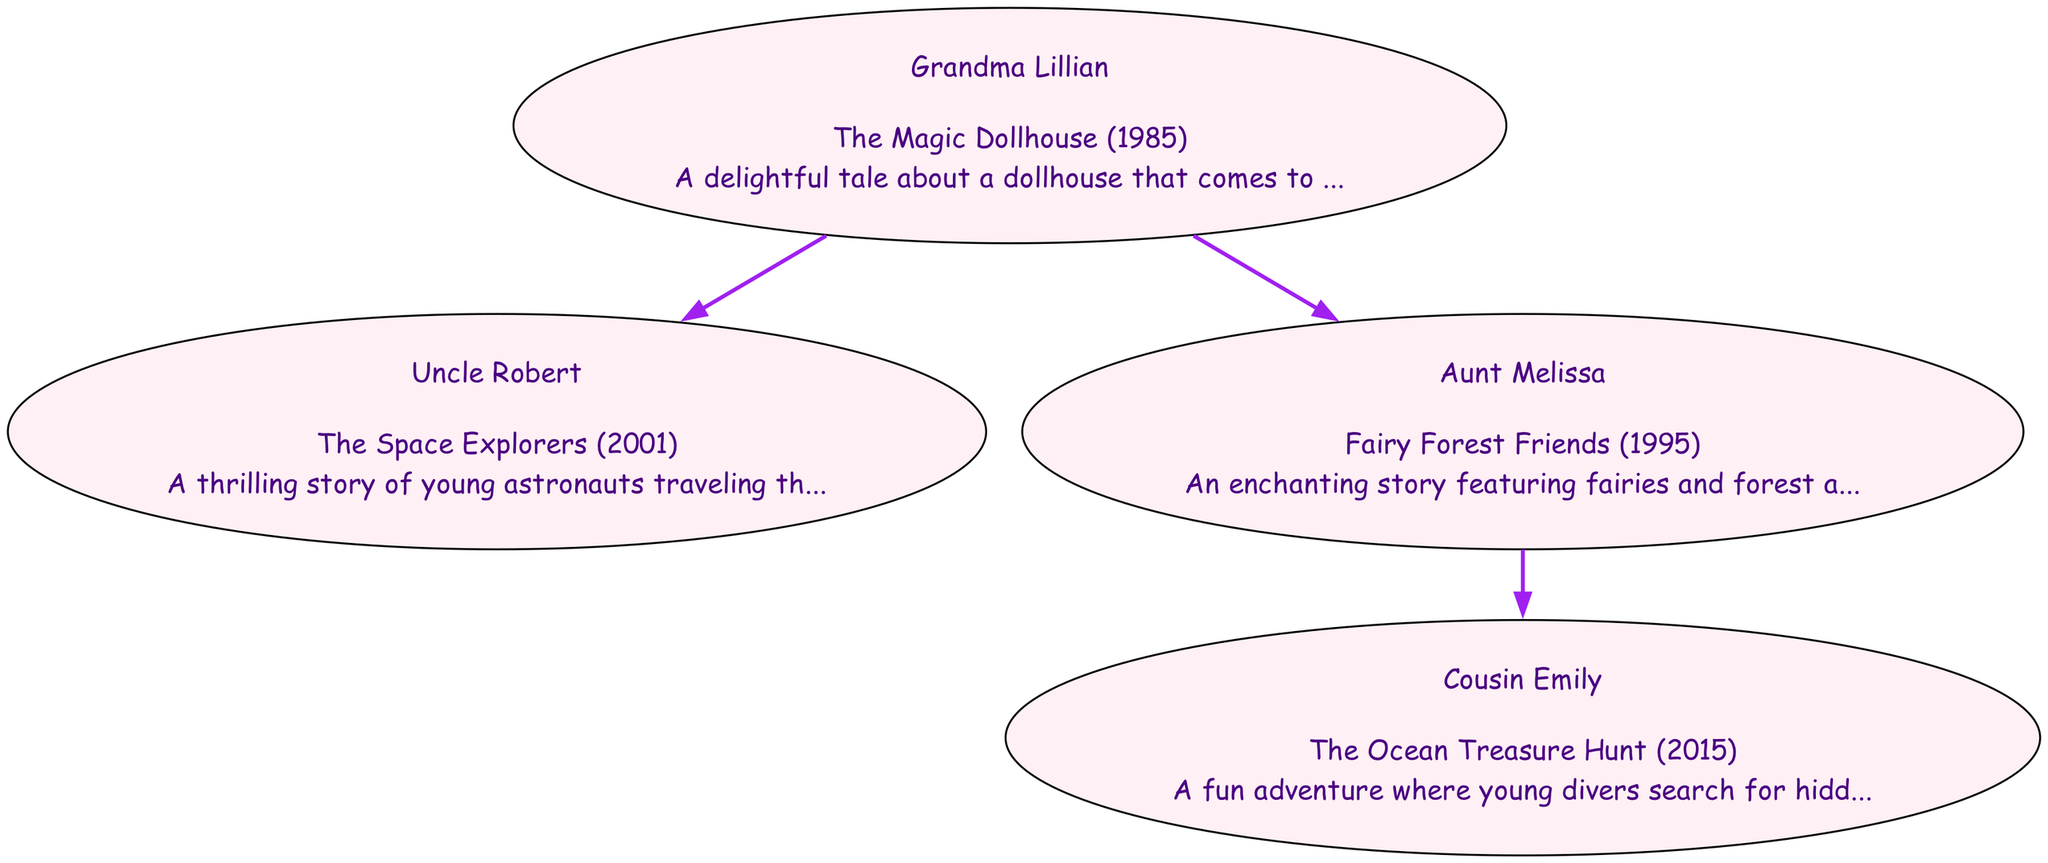What is the title of Grandma Lillian's book? The diagram shows that Grandma Lillian authored "The Magic Dollhouse."
Answer: The Magic Dollhouse How many books has Uncle Robert written? Uncle Robert has written one book titled "The Space Explorers," as indicated in the diagram.
Answer: 1 Which family member authored "Fairy Forest Friends"? Looking at the diagram, it is clear that "Fairy Forest Friends" was authored by Aunt Melissa.
Answer: Aunt Melissa What year was "The Ocean Treasure Hunt" published? The diagram indicates that "The Ocean Treasure Hunt" was published in 2015.
Answer: 2015 Who is the child of Aunt Melissa? According to the diagram, the child of Aunt Melissa is Cousin Emily.
Answer: Cousin Emily What relationship is Uncle Robert to Grandma Lillian? The diagram illustrates that Uncle Robert is a child of Grandma Lillian.
Answer: Child In total, how many children have authored books in this family tree? Analyzing the diagram shows that there are three children who authored books: Uncle Robert, Aunt Melissa, and Cousin Emily.
Answer: 3 Which book features fairies and forest animals? The diagram states that "Fairy Forest Friends" features fairies and forest animals.
Answer: Fairy Forest Friends What type of adventure are the characters in "The Space Explorers" undertaking? The diagram describes "The Space Explorers" as a story about young astronauts traveling through space.
Answer: Space adventure How many nodes are there in the family tree? Evaluating the diagram reveals a total of five nodes representing family members and their books.
Answer: 5 